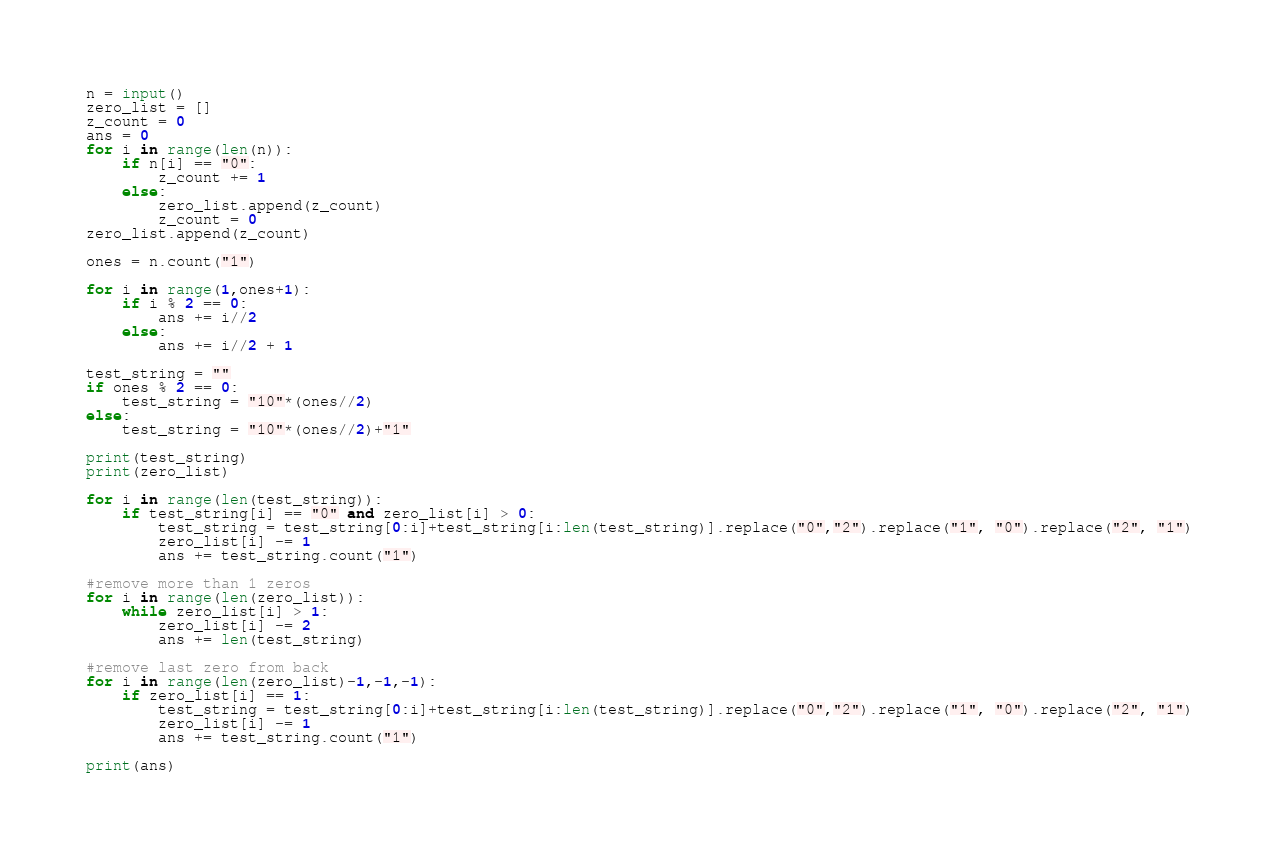<code> <loc_0><loc_0><loc_500><loc_500><_Python_>
n = input()
zero_list = []
z_count = 0
ans = 0
for i in range(len(n)):
    if n[i] == "0":
        z_count += 1
    else:
        zero_list.append(z_count)
        z_count = 0
zero_list.append(z_count)

ones = n.count("1")

for i in range(1,ones+1):
    if i % 2 == 0:
        ans += i//2
    else:
        ans += i//2 + 1
             
test_string = ""
if ones % 2 == 0:
    test_string = "10"*(ones//2)
else:
    test_string = "10"*(ones//2)+"1"

print(test_string)
print(zero_list)

for i in range(len(test_string)):
    if test_string[i] == "0" and zero_list[i] > 0:
        test_string = test_string[0:i]+test_string[i:len(test_string)].replace("0","2").replace("1", "0").replace("2", "1") 
        zero_list[i] -= 1
        ans += test_string.count("1")

#remove more than 1 zeros
for i in range(len(zero_list)):
    while zero_list[i] > 1:
        zero_list[i] -= 2
        ans += len(test_string)

#remove last zero from back
for i in range(len(zero_list)-1,-1,-1):
    if zero_list[i] == 1:
        test_string = test_string[0:i]+test_string[i:len(test_string)].replace("0","2").replace("1", "0").replace("2", "1") 
        zero_list[i] -= 1
        ans += test_string.count("1")

print(ans)
</code> 